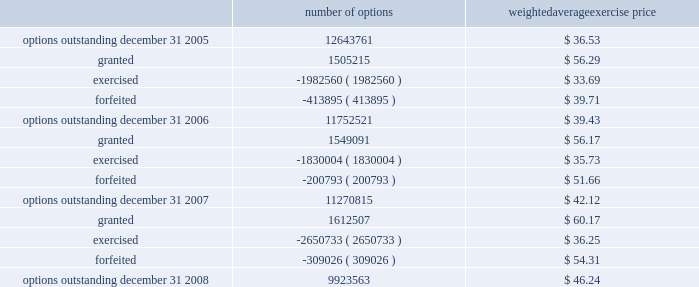N o t e s t o c o n s o l i d a t e d f i n a n c i a l s t a t e m e n t s ( continued ) ace limited and subsidiaries the table shows changes in the company 2019s stock options for the years ended december 31 , 2008 , 2007 , and number of options weighted average exercise price .
The weighted-average remaining contractual term was 5.8 years for the stock options outstanding and 4.6 years for the stock options exercisable at december 31 , 2008 .
The total intrinsic value was approximately $ 66 million for stock options out- standing and $ 81 million for stock options exercisable at december 31 , 2008 .
The weighted-average fair value for the stock options granted for the year ended december 31 , 2008 was $ 17.60 .
The total intrinsic value for stock options exercised dur- ing the years ended december 31 , 2008 , 2007 , and 2006 , was approximately $ 54 million , $ 44 million , and $ 43 million , respectively .
The amount of cash received during the year ended december 31 , 2008 , from the exercise of stock options was $ 97 million .
Restricted stock the company 2019s 2004 ltip also provides for grants of restricted stock .
The company generally grants restricted stock with a 4-year vesting period , based on a graded vesting schedule .
The restricted stock is granted at market close price on the date of grant .
Included in the company 2019s share-based compensation expense in the year ended december 31 , 2008 , is a portion of the cost related to the unvested restricted stock granted in the years 2004 to 2008. .
What is the percentage change in the balance of outstanding options from 2005 to 2008? 
Computations: ((9923563 - 12643761) / 12643761)
Answer: -0.21514. 